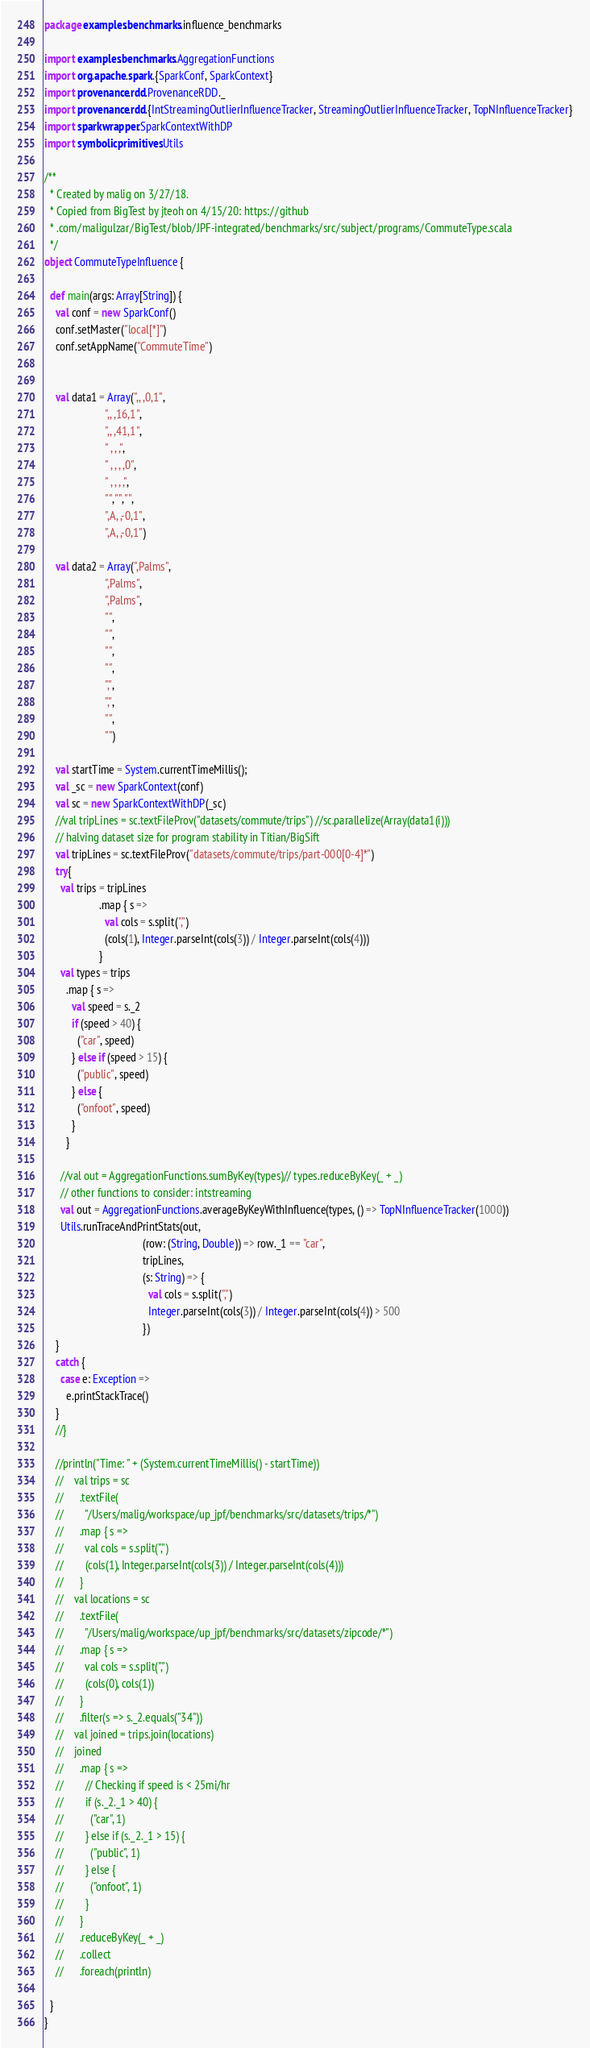Convert code to text. <code><loc_0><loc_0><loc_500><loc_500><_Scala_>package examples.benchmarks.influence_benchmarks

import examples.benchmarks.AggregationFunctions
import org.apache.spark.{SparkConf, SparkContext}
import provenance.rdd.ProvenanceRDD._
import provenance.rdd.{IntStreamingOutlierInfluenceTracker, StreamingOutlierInfluenceTracker, TopNInfluenceTracker}
import sparkwrapper.SparkContextWithDP
import symbolicprimitives.Utils

/**
  * Created by malig on 3/27/18.
  * Copied from BigTest by jteoh on 4/15/20: https://github
  * .com/maligulzar/BigTest/blob/JPF-integrated/benchmarks/src/subject/programs/CommuteType.scala
  */
object CommuteTypeInfluence {
  
  def main(args: Array[String]) {
    val conf = new SparkConf()
    conf.setMaster("local[*]")
    conf.setAppName("CommuteTime")
    
    
    val data1 = Array(",, ,0,1",
                      ",, ,16,1",
                      ",, ,41,1",
                      " , , ,",
                      " , , , ,0",
                      " , , , ,",
                      "","","",
                      ",A, ,-0,1",
                      ",A, ,-0,1")
    
    val data2 = Array(",Palms",
                      ",Palms",
                      ",Palms",
                      "",
                      "",
                      "",
                      "",
                      ",",
                      ",",
                      "",
                      "")
    
    val startTime = System.currentTimeMillis();
    val _sc = new SparkContext(conf)
    val sc = new SparkContextWithDP(_sc)
    //val tripLines = sc.textFileProv("datasets/commute/trips") //sc.parallelize(Array(data1(i)))
    // halving dataset size for program stability in Titian/BigSift
    val tripLines = sc.textFileProv("datasets/commute/trips/part-000[0-4]*")
    try{
      val trips = tripLines
                    .map { s =>
                      val cols = s.split(",")
                      (cols(1), Integer.parseInt(cols(3)) / Integer.parseInt(cols(4)))
                    }
      val types = trips
        .map { s =>
          val speed = s._2
          if (speed > 40) {
            ("car", speed)
          } else if (speed > 15) {
            ("public", speed)
          } else {
            ("onfoot", speed)
          }
        }
        
      //val out = AggregationFunctions.sumByKey(types)// types.reduceByKey(_ + _)
      // other functions to consider: intstreaming
      val out = AggregationFunctions.averageByKeyWithInfluence(types, () => TopNInfluenceTracker(1000))
      Utils.runTraceAndPrintStats(out,
                                    (row: (String, Double)) => row._1 == "car",
                                    tripLines,
                                    (s: String) => {
                                      val cols = s.split(",")
                                      Integer.parseInt(cols(3)) / Integer.parseInt(cols(4)) > 500
                                    })
    }
    catch {
      case e: Exception =>
        e.printStackTrace()
    }
    //}
    
    //println("Time: " + (System.currentTimeMillis() - startTime))
    //    val trips = sc
    //      .textFile(
    //        "/Users/malig/workspace/up_jpf/benchmarks/src/datasets/trips/*")
    //      .map { s =>
    //        val cols = s.split(",")
    //        (cols(1), Integer.parseInt(cols(3)) / Integer.parseInt(cols(4)))
    //      }
    //    val locations = sc
    //      .textFile(
    //        "/Users/malig/workspace/up_jpf/benchmarks/src/datasets/zipcode/*")
    //      .map { s =>
    //        val cols = s.split(",")
    //        (cols(0), cols(1))
    //      }
    //      .filter(s => s._2.equals("34"))
    //    val joined = trips.join(locations)
    //    joined
    //      .map { s =>
    //        // Checking if speed is < 25mi/hr
    //        if (s._2._1 > 40) {
    //          ("car", 1)
    //        } else if (s._2._1 > 15) {
    //          ("public", 1)
    //        } else {
    //          ("onfoot", 1)
    //        }
    //      }
    //      .reduceByKey(_ + _)
    //      .collect
    //      .foreach(println)
    
  }
}
</code> 